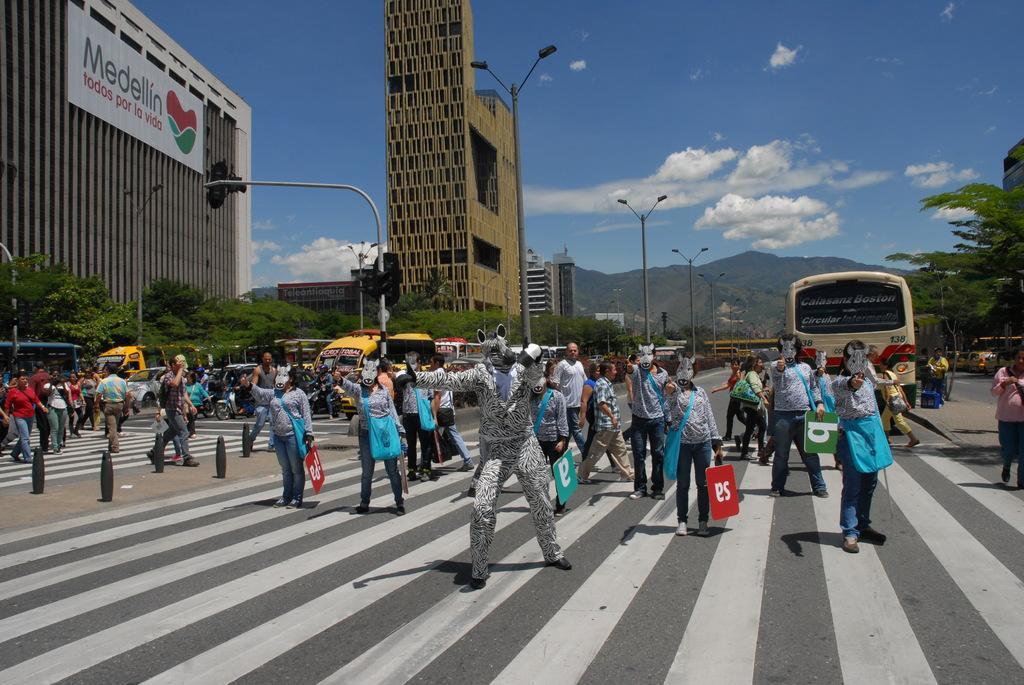Could you give a brief overview of what you see in this image? There are roads. On the roads there are zebra crossings. Also there are many people. Some are wearing mask and holding placards. There are many vehicles. In the back there are light poles, buildings, trees, hills and sky with clouds. On the building there is a name board. 